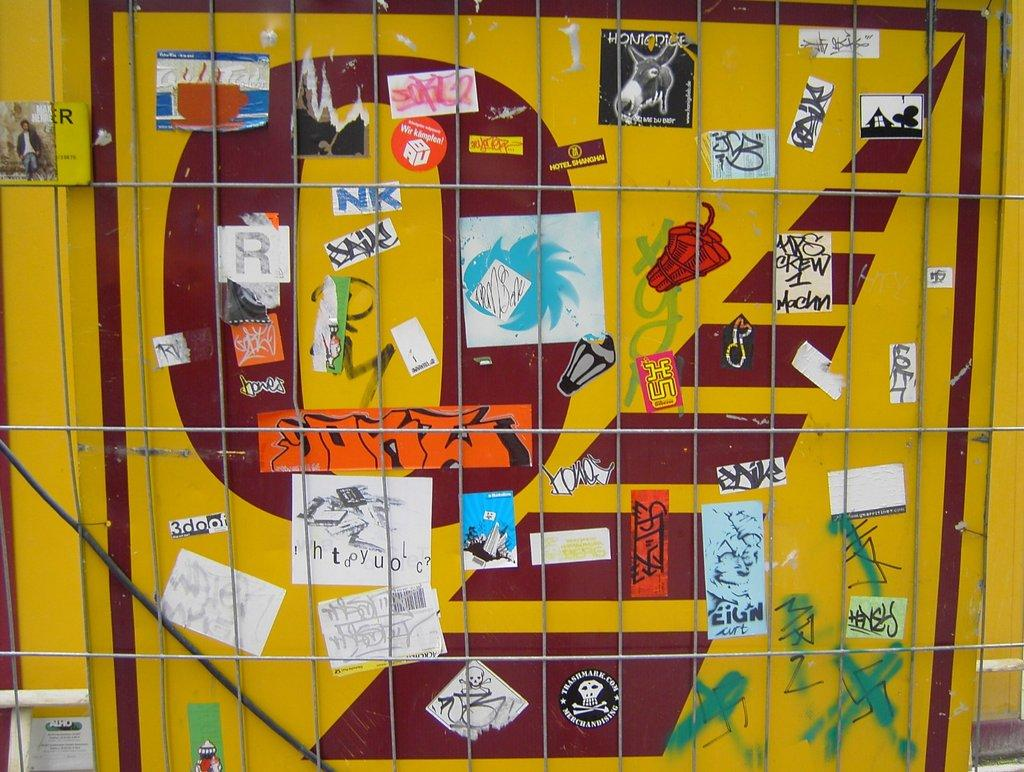What is located in the foreground of the image? There is a mesh in the foreground of the image. What can be seen on the yellow color board in the image? There are posters on the yellow color board in the image. Where is the faucet located in the image? There is no faucet present in the image. What type of coal is visible in the image? There is no coal present in the image. 